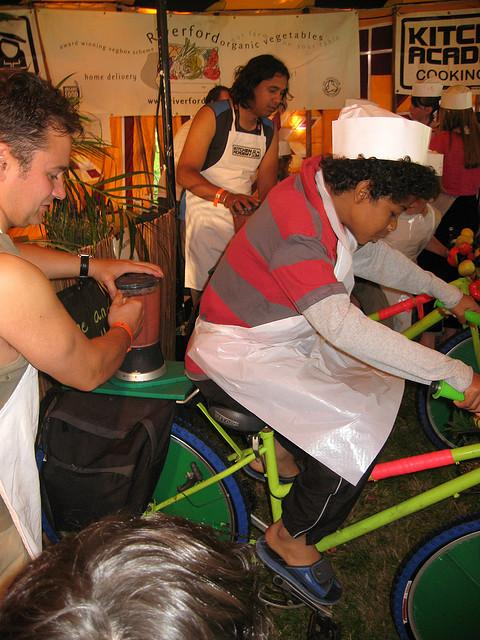What does the person in the white hat power? Please explain your reasoning. blender. The person in the white hat has a blender on his bike. 